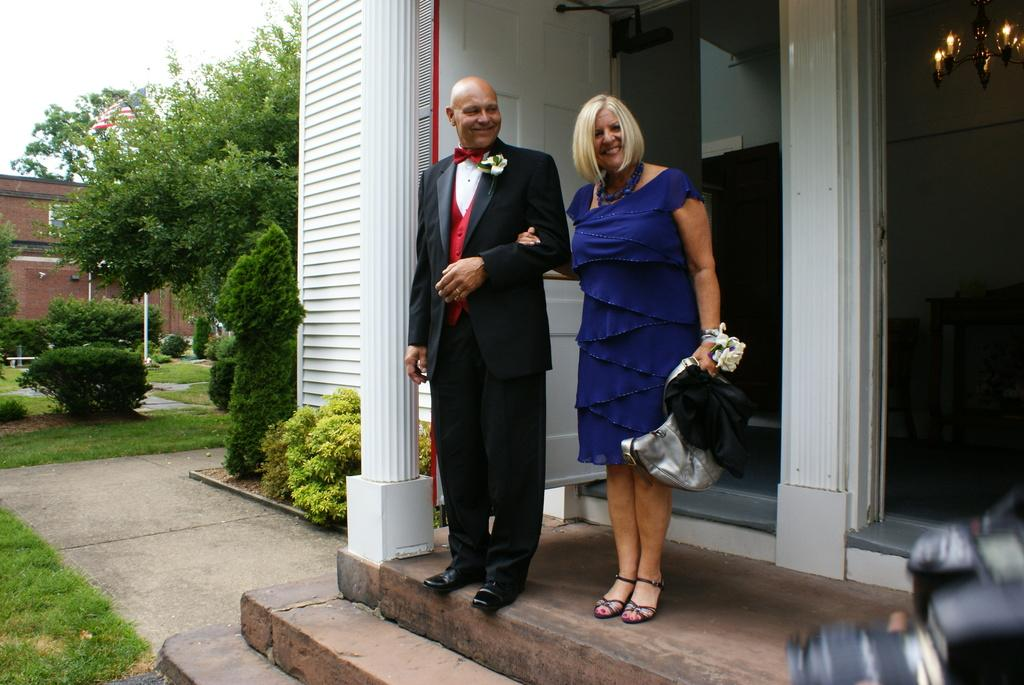Who is present in the image? There is a man and a woman in the image. What are they doing in the image? The man and woman are standing in front of a door and posing for a photo. What can be seen in the background of the image? There are trees and plants in the image. Where is the camera located in the image? The camera is on the right side of the image. What type of bean is being used as a prop in the image? There is no bean present in the image; it features a man and a woman posing for a photo in front of a door. 